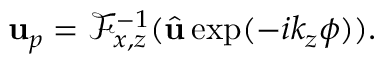<formula> <loc_0><loc_0><loc_500><loc_500>u _ { p } = \mathcal { F } _ { x , z } ^ { - 1 } ( \hat { u } \exp ( - i k _ { z } \phi ) ) .</formula> 